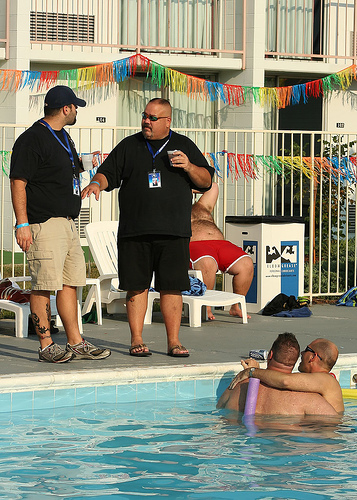<image>
Can you confirm if the man is next to the man? No. The man is not positioned next to the man. They are located in different areas of the scene. Where is the slipper in relation to the water? Is it above the water? No. The slipper is not positioned above the water. The vertical arrangement shows a different relationship. 